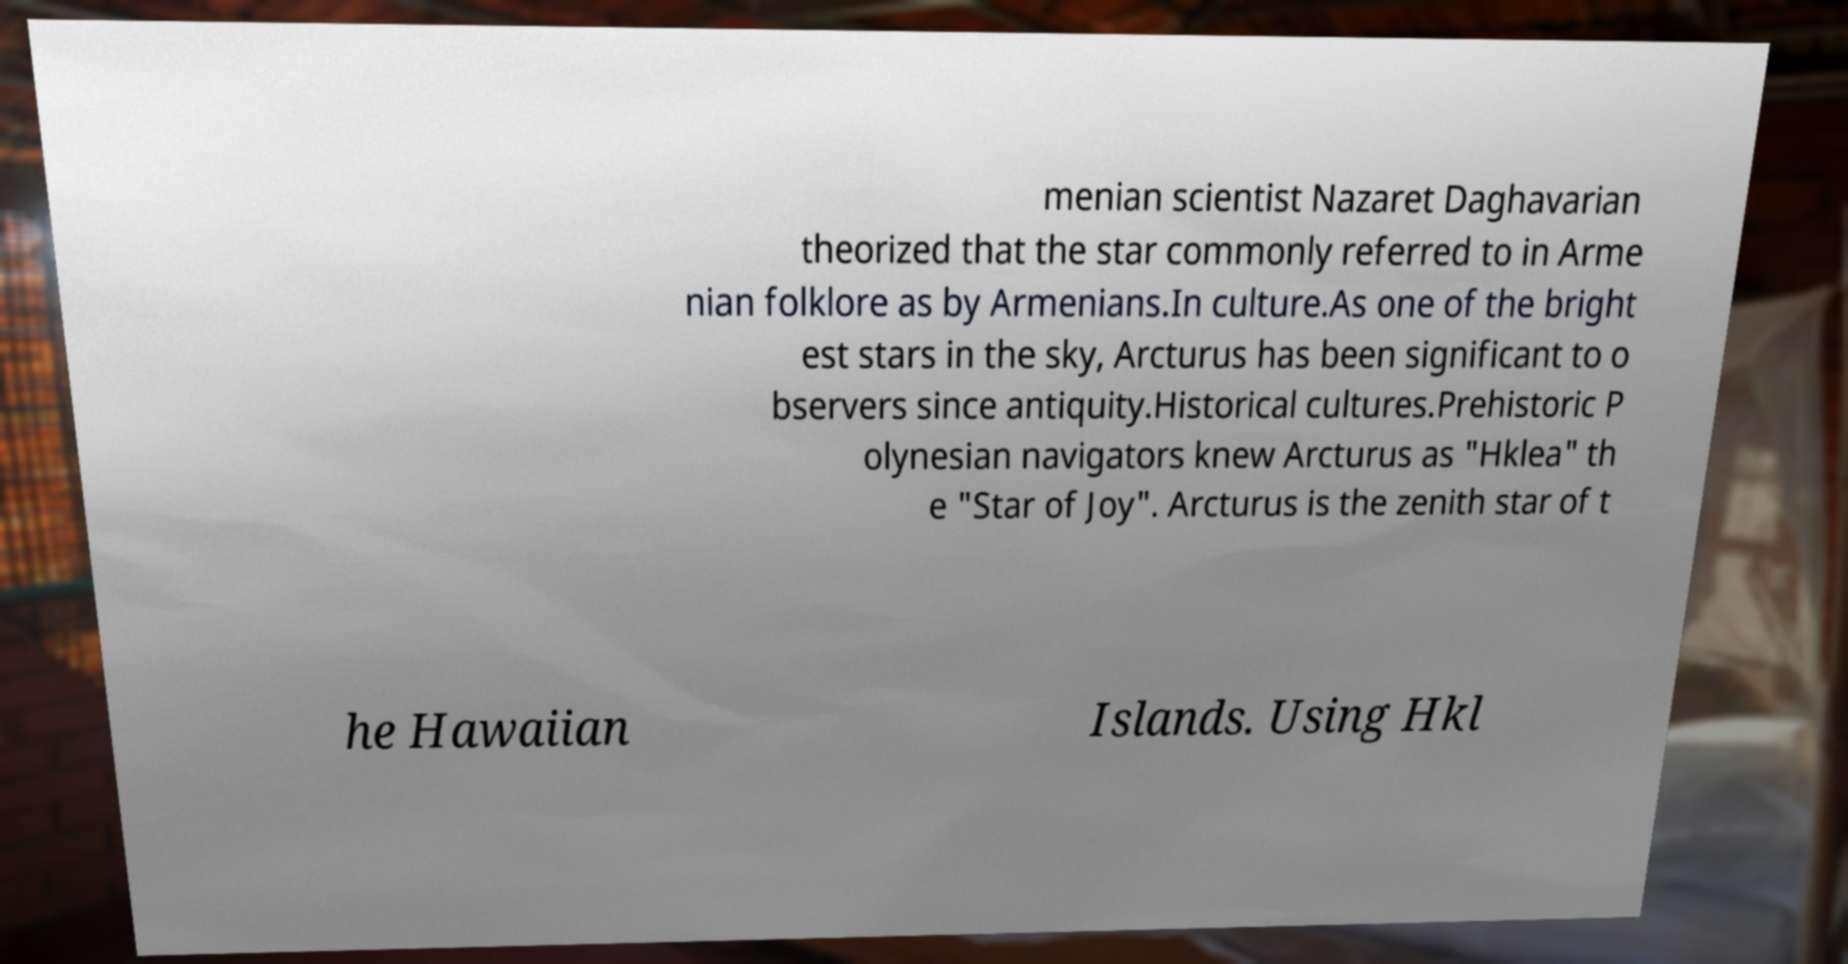I need the written content from this picture converted into text. Can you do that? menian scientist Nazaret Daghavarian theorized that the star commonly referred to in Arme nian folklore as by Armenians.In culture.As one of the bright est stars in the sky, Arcturus has been significant to o bservers since antiquity.Historical cultures.Prehistoric P olynesian navigators knew Arcturus as "Hklea" th e "Star of Joy". Arcturus is the zenith star of t he Hawaiian Islands. Using Hkl 